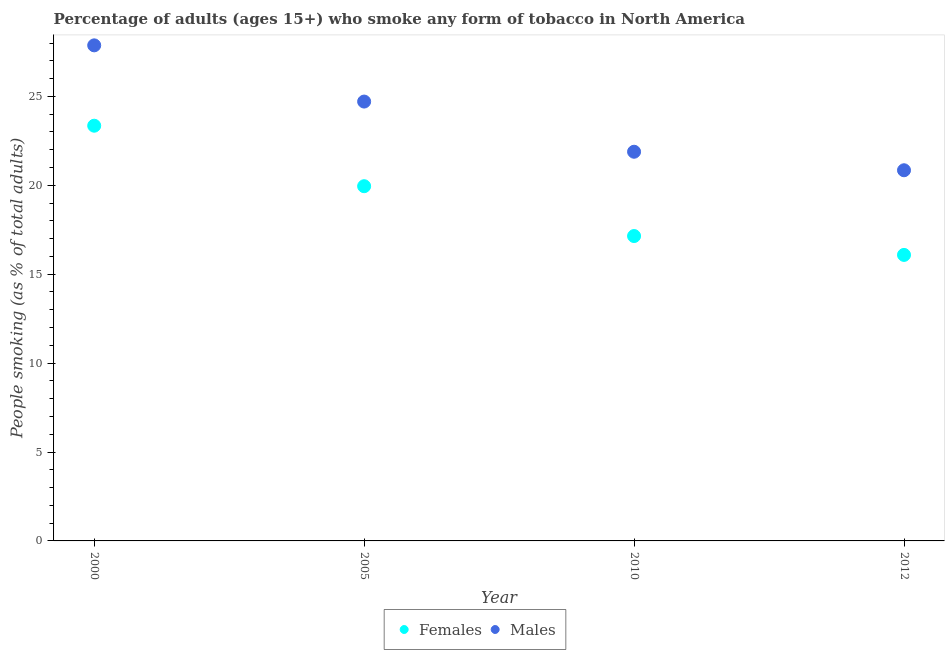What is the percentage of females who smoke in 2010?
Offer a very short reply. 17.15. Across all years, what is the maximum percentage of males who smoke?
Your answer should be compact. 27.87. Across all years, what is the minimum percentage of males who smoke?
Provide a succinct answer. 20.85. In which year was the percentage of females who smoke maximum?
Offer a very short reply. 2000. What is the total percentage of males who smoke in the graph?
Make the answer very short. 95.32. What is the difference between the percentage of males who smoke in 2005 and that in 2012?
Ensure brevity in your answer.  3.86. What is the difference between the percentage of females who smoke in 2010 and the percentage of males who smoke in 2005?
Provide a succinct answer. -7.56. What is the average percentage of females who smoke per year?
Your answer should be very brief. 19.13. In the year 2010, what is the difference between the percentage of males who smoke and percentage of females who smoke?
Provide a succinct answer. 4.74. In how many years, is the percentage of males who smoke greater than 27 %?
Ensure brevity in your answer.  1. What is the ratio of the percentage of males who smoke in 2010 to that in 2012?
Keep it short and to the point. 1.05. Is the percentage of males who smoke in 2000 less than that in 2010?
Provide a succinct answer. No. Is the difference between the percentage of females who smoke in 2005 and 2012 greater than the difference between the percentage of males who smoke in 2005 and 2012?
Keep it short and to the point. Yes. What is the difference between the highest and the second highest percentage of males who smoke?
Provide a short and direct response. 3.16. What is the difference between the highest and the lowest percentage of females who smoke?
Your answer should be compact. 7.27. In how many years, is the percentage of males who smoke greater than the average percentage of males who smoke taken over all years?
Keep it short and to the point. 2. Is the sum of the percentage of females who smoke in 2010 and 2012 greater than the maximum percentage of males who smoke across all years?
Provide a succinct answer. Yes. Does the percentage of females who smoke monotonically increase over the years?
Keep it short and to the point. No. Is the percentage of males who smoke strictly less than the percentage of females who smoke over the years?
Provide a short and direct response. No. How many dotlines are there?
Provide a succinct answer. 2. How many years are there in the graph?
Make the answer very short. 4. Are the values on the major ticks of Y-axis written in scientific E-notation?
Offer a very short reply. No. Where does the legend appear in the graph?
Offer a terse response. Bottom center. How many legend labels are there?
Give a very brief answer. 2. How are the legend labels stacked?
Make the answer very short. Horizontal. What is the title of the graph?
Your answer should be very brief. Percentage of adults (ages 15+) who smoke any form of tobacco in North America. What is the label or title of the Y-axis?
Your answer should be compact. People smoking (as % of total adults). What is the People smoking (as % of total adults) in Females in 2000?
Your answer should be compact. 23.35. What is the People smoking (as % of total adults) in Males in 2000?
Provide a short and direct response. 27.87. What is the People smoking (as % of total adults) of Females in 2005?
Give a very brief answer. 19.95. What is the People smoking (as % of total adults) in Males in 2005?
Provide a short and direct response. 24.71. What is the People smoking (as % of total adults) in Females in 2010?
Provide a short and direct response. 17.15. What is the People smoking (as % of total adults) of Males in 2010?
Your answer should be compact. 21.89. What is the People smoking (as % of total adults) in Females in 2012?
Keep it short and to the point. 16.09. What is the People smoking (as % of total adults) in Males in 2012?
Make the answer very short. 20.85. Across all years, what is the maximum People smoking (as % of total adults) in Females?
Offer a very short reply. 23.35. Across all years, what is the maximum People smoking (as % of total adults) of Males?
Provide a short and direct response. 27.87. Across all years, what is the minimum People smoking (as % of total adults) in Females?
Keep it short and to the point. 16.09. Across all years, what is the minimum People smoking (as % of total adults) of Males?
Give a very brief answer. 20.85. What is the total People smoking (as % of total adults) in Females in the graph?
Make the answer very short. 76.54. What is the total People smoking (as % of total adults) of Males in the graph?
Make the answer very short. 95.32. What is the difference between the People smoking (as % of total adults) in Females in 2000 and that in 2005?
Provide a short and direct response. 3.4. What is the difference between the People smoking (as % of total adults) in Males in 2000 and that in 2005?
Your answer should be compact. 3.16. What is the difference between the People smoking (as % of total adults) of Females in 2000 and that in 2010?
Give a very brief answer. 6.2. What is the difference between the People smoking (as % of total adults) in Males in 2000 and that in 2010?
Provide a succinct answer. 5.98. What is the difference between the People smoking (as % of total adults) of Females in 2000 and that in 2012?
Ensure brevity in your answer.  7.27. What is the difference between the People smoking (as % of total adults) of Males in 2000 and that in 2012?
Offer a terse response. 7.02. What is the difference between the People smoking (as % of total adults) of Females in 2005 and that in 2010?
Your answer should be very brief. 2.8. What is the difference between the People smoking (as % of total adults) in Males in 2005 and that in 2010?
Give a very brief answer. 2.82. What is the difference between the People smoking (as % of total adults) of Females in 2005 and that in 2012?
Provide a succinct answer. 3.86. What is the difference between the People smoking (as % of total adults) of Males in 2005 and that in 2012?
Your response must be concise. 3.86. What is the difference between the People smoking (as % of total adults) of Females in 2010 and that in 2012?
Your answer should be compact. 1.06. What is the difference between the People smoking (as % of total adults) of Males in 2010 and that in 2012?
Offer a very short reply. 1.04. What is the difference between the People smoking (as % of total adults) of Females in 2000 and the People smoking (as % of total adults) of Males in 2005?
Offer a very short reply. -1.36. What is the difference between the People smoking (as % of total adults) in Females in 2000 and the People smoking (as % of total adults) in Males in 2010?
Your response must be concise. 1.46. What is the difference between the People smoking (as % of total adults) of Females in 2000 and the People smoking (as % of total adults) of Males in 2012?
Ensure brevity in your answer.  2.51. What is the difference between the People smoking (as % of total adults) in Females in 2005 and the People smoking (as % of total adults) in Males in 2010?
Ensure brevity in your answer.  -1.94. What is the difference between the People smoking (as % of total adults) of Females in 2005 and the People smoking (as % of total adults) of Males in 2012?
Your answer should be very brief. -0.9. What is the difference between the People smoking (as % of total adults) in Females in 2010 and the People smoking (as % of total adults) in Males in 2012?
Offer a terse response. -3.7. What is the average People smoking (as % of total adults) in Females per year?
Keep it short and to the point. 19.13. What is the average People smoking (as % of total adults) in Males per year?
Your answer should be compact. 23.83. In the year 2000, what is the difference between the People smoking (as % of total adults) of Females and People smoking (as % of total adults) of Males?
Offer a terse response. -4.52. In the year 2005, what is the difference between the People smoking (as % of total adults) of Females and People smoking (as % of total adults) of Males?
Your answer should be very brief. -4.76. In the year 2010, what is the difference between the People smoking (as % of total adults) of Females and People smoking (as % of total adults) of Males?
Your response must be concise. -4.74. In the year 2012, what is the difference between the People smoking (as % of total adults) of Females and People smoking (as % of total adults) of Males?
Give a very brief answer. -4.76. What is the ratio of the People smoking (as % of total adults) in Females in 2000 to that in 2005?
Your response must be concise. 1.17. What is the ratio of the People smoking (as % of total adults) of Males in 2000 to that in 2005?
Your response must be concise. 1.13. What is the ratio of the People smoking (as % of total adults) of Females in 2000 to that in 2010?
Give a very brief answer. 1.36. What is the ratio of the People smoking (as % of total adults) of Males in 2000 to that in 2010?
Keep it short and to the point. 1.27. What is the ratio of the People smoking (as % of total adults) of Females in 2000 to that in 2012?
Your answer should be very brief. 1.45. What is the ratio of the People smoking (as % of total adults) of Males in 2000 to that in 2012?
Your answer should be compact. 1.34. What is the ratio of the People smoking (as % of total adults) in Females in 2005 to that in 2010?
Your answer should be very brief. 1.16. What is the ratio of the People smoking (as % of total adults) in Males in 2005 to that in 2010?
Offer a very short reply. 1.13. What is the ratio of the People smoking (as % of total adults) in Females in 2005 to that in 2012?
Offer a terse response. 1.24. What is the ratio of the People smoking (as % of total adults) in Males in 2005 to that in 2012?
Your response must be concise. 1.19. What is the ratio of the People smoking (as % of total adults) in Females in 2010 to that in 2012?
Give a very brief answer. 1.07. What is the ratio of the People smoking (as % of total adults) of Males in 2010 to that in 2012?
Keep it short and to the point. 1.05. What is the difference between the highest and the second highest People smoking (as % of total adults) of Females?
Your answer should be compact. 3.4. What is the difference between the highest and the second highest People smoking (as % of total adults) in Males?
Ensure brevity in your answer.  3.16. What is the difference between the highest and the lowest People smoking (as % of total adults) of Females?
Offer a terse response. 7.27. What is the difference between the highest and the lowest People smoking (as % of total adults) in Males?
Keep it short and to the point. 7.02. 